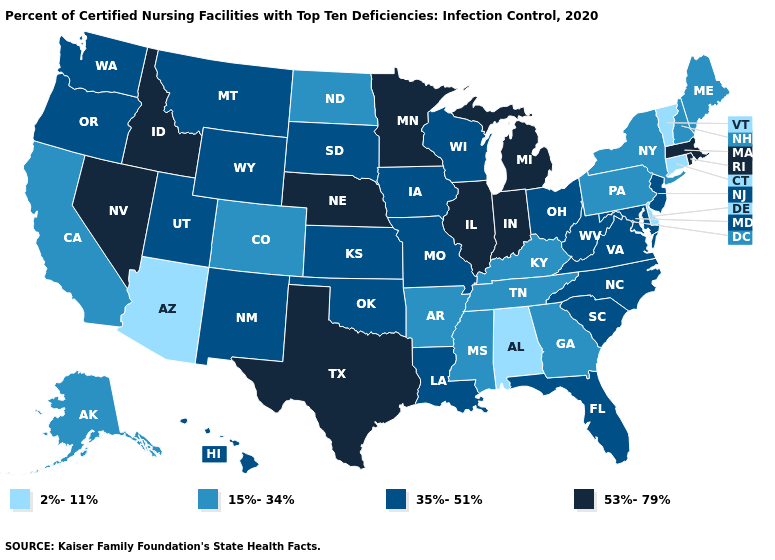Does the map have missing data?
Short answer required. No. Name the states that have a value in the range 15%-34%?
Keep it brief. Alaska, Arkansas, California, Colorado, Georgia, Kentucky, Maine, Mississippi, New Hampshire, New York, North Dakota, Pennsylvania, Tennessee. Which states hav the highest value in the South?
Quick response, please. Texas. How many symbols are there in the legend?
Be succinct. 4. Name the states that have a value in the range 15%-34%?
Give a very brief answer. Alaska, Arkansas, California, Colorado, Georgia, Kentucky, Maine, Mississippi, New Hampshire, New York, North Dakota, Pennsylvania, Tennessee. Name the states that have a value in the range 35%-51%?
Answer briefly. Florida, Hawaii, Iowa, Kansas, Louisiana, Maryland, Missouri, Montana, New Jersey, New Mexico, North Carolina, Ohio, Oklahoma, Oregon, South Carolina, South Dakota, Utah, Virginia, Washington, West Virginia, Wisconsin, Wyoming. Does the map have missing data?
Be succinct. No. What is the lowest value in the USA?
Short answer required. 2%-11%. Which states have the lowest value in the USA?
Short answer required. Alabama, Arizona, Connecticut, Delaware, Vermont. Among the states that border Oregon , which have the highest value?
Quick response, please. Idaho, Nevada. Does North Dakota have the same value as New York?
Answer briefly. Yes. Name the states that have a value in the range 35%-51%?
Keep it brief. Florida, Hawaii, Iowa, Kansas, Louisiana, Maryland, Missouri, Montana, New Jersey, New Mexico, North Carolina, Ohio, Oklahoma, Oregon, South Carolina, South Dakota, Utah, Virginia, Washington, West Virginia, Wisconsin, Wyoming. Name the states that have a value in the range 35%-51%?
Concise answer only. Florida, Hawaii, Iowa, Kansas, Louisiana, Maryland, Missouri, Montana, New Jersey, New Mexico, North Carolina, Ohio, Oklahoma, Oregon, South Carolina, South Dakota, Utah, Virginia, Washington, West Virginia, Wisconsin, Wyoming. Does Nebraska have the lowest value in the MidWest?
Answer briefly. No. 